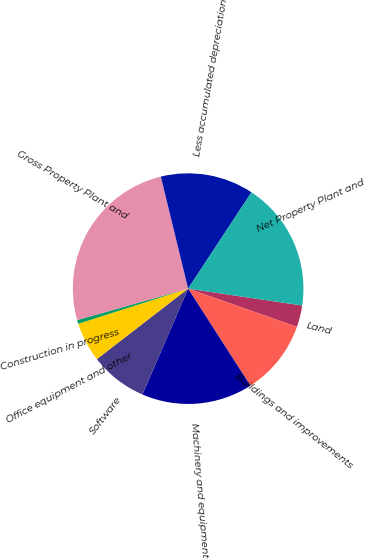<chart> <loc_0><loc_0><loc_500><loc_500><pie_chart><fcel>Land<fcel>Buildings and improvements<fcel>Machinery and equipment<fcel>Software<fcel>Office equipment and other<fcel>Construction in progress<fcel>Gross Property Plant and<fcel>Less accumulated depreciation<fcel>Net Property Plant and<nl><fcel>3.03%<fcel>10.55%<fcel>15.57%<fcel>8.05%<fcel>5.54%<fcel>0.53%<fcel>25.6%<fcel>13.06%<fcel>18.08%<nl></chart> 